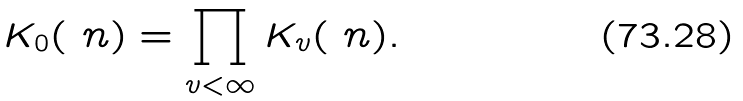Convert formula to latex. <formula><loc_0><loc_0><loc_500><loc_500>K _ { 0 } ( \ n ) = \prod _ { v < \infty } K _ { v } ( \ n ) .</formula> 